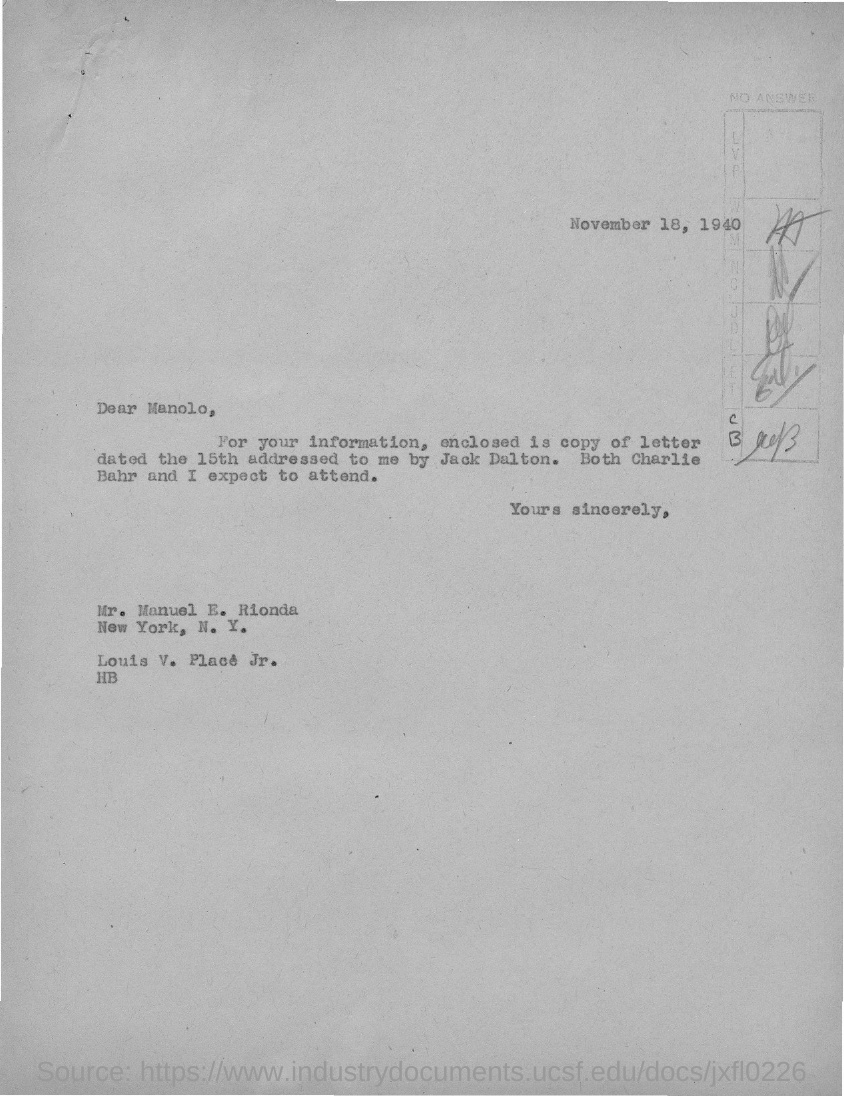When is the letter dated?
Offer a very short reply. November 18, 1940. To whom the letter is written?
Offer a terse response. Manolo. 